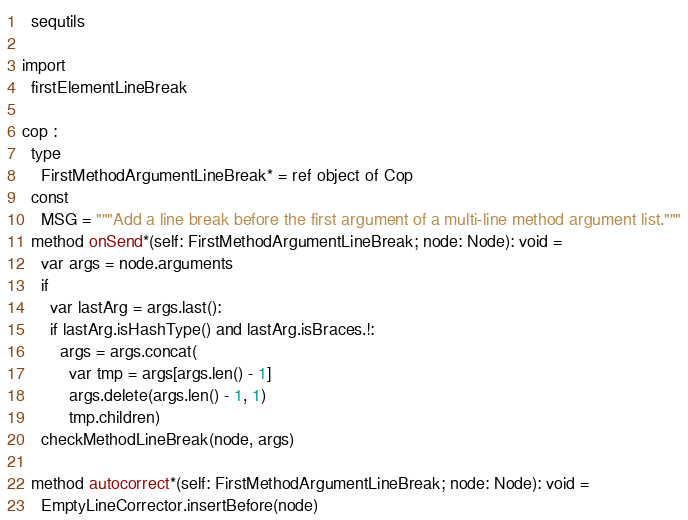<code> <loc_0><loc_0><loc_500><loc_500><_Nim_>  sequtils

import
  firstElementLineBreak

cop :
  type
    FirstMethodArgumentLineBreak* = ref object of Cop
  const
    MSG = """Add a line break before the first argument of a multi-line method argument list."""
  method onSend*(self: FirstMethodArgumentLineBreak; node: Node): void =
    var args = node.arguments
    if
      var lastArg = args.last():
      if lastArg.isHashType() and lastArg.isBraces.!:
        args = args.concat(
          var tmp = args[args.len() - 1]
          args.delete(args.len() - 1, 1)
          tmp.children)
    checkMethodLineBreak(node, args)

  method autocorrect*(self: FirstMethodArgumentLineBreak; node: Node): void =
    EmptyLineCorrector.insertBefore(node)

</code> 